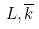Convert formula to latex. <formula><loc_0><loc_0><loc_500><loc_500>L , \overline { k }</formula> 